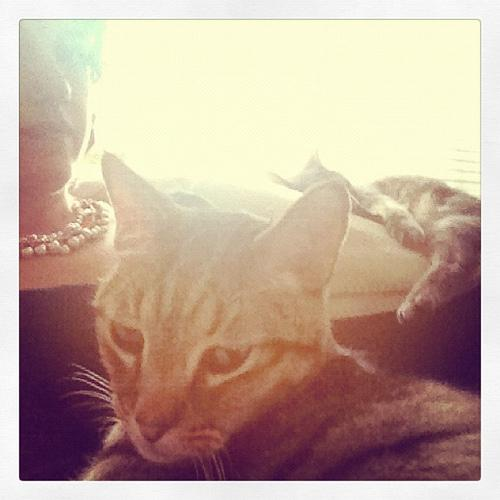Question: why was the picture taken?
Choices:
A. To capture the dogs.
B. To capture the cats.
C. To capture the moment.
D. Capture the occasion.
Answer with the letter. Answer: B Question: who is the picture?
Choices:
A. Two cats and a woman.
B. Twins.
C. Triplets.
D. Horses.
Answer with the letter. Answer: A Question: what color top is the woman wearing?
Choices:
A. Pink.
B. Black.
C. Red.
D. Blue.
Answer with the letter. Answer: B 